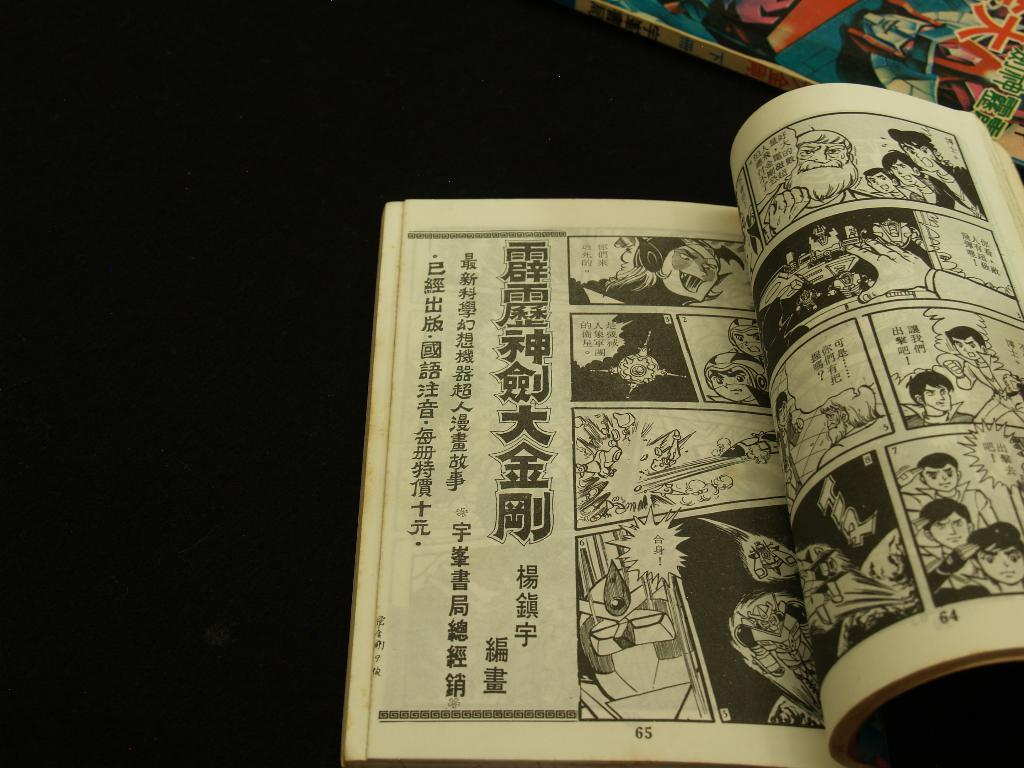<image>
Share a concise interpretation of the image provided. A black and white comic bank is opened to pages 64 and 65. 